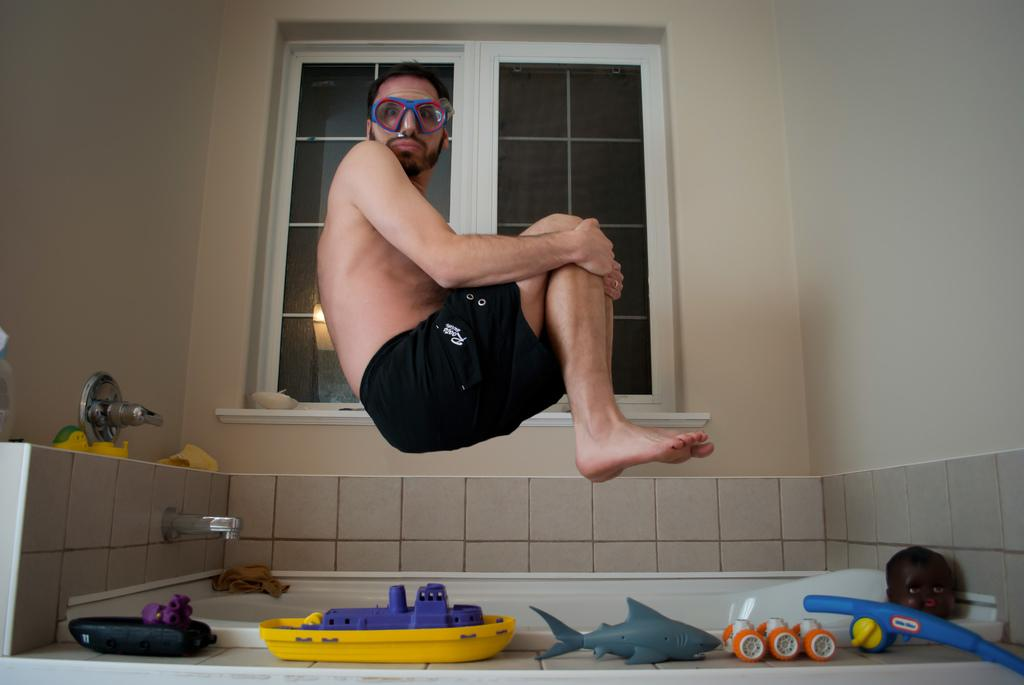Who is present in the image? There is a man in the image. What is the man wearing on his face? The man is wearing goggles. What type of clothing is the man wearing on his lower body? The man is wearing black-colored shorts. What is the main object in the image? There is a bathtub in the image. What is used to control the flow of water in the image? There is a water tap in the image. What type of objects can be seen in the image that are typically associated with children? There are toys in the image. What can be seen in the background of the image? There is a window visible in the background of the image. What type of volcano can be seen erupting in the image? There is no volcano present in the image; it features a man in a bathtub with toys and a water tap. What type of vessel is being used to carry water in the image? There is no vessel present in the image; the water tap is used to control the flow of water. 